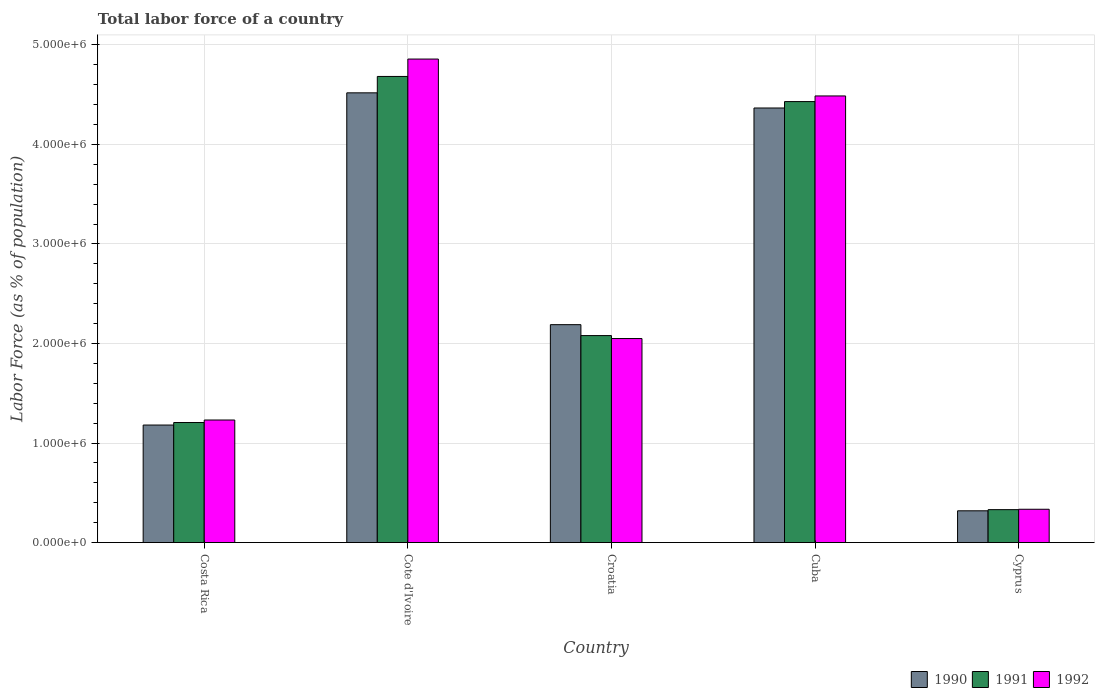How many different coloured bars are there?
Your answer should be compact. 3. Are the number of bars per tick equal to the number of legend labels?
Your answer should be very brief. Yes. Are the number of bars on each tick of the X-axis equal?
Ensure brevity in your answer.  Yes. How many bars are there on the 2nd tick from the left?
Offer a terse response. 3. What is the label of the 3rd group of bars from the left?
Offer a very short reply. Croatia. What is the percentage of labor force in 1992 in Cote d'Ivoire?
Your answer should be compact. 4.86e+06. Across all countries, what is the maximum percentage of labor force in 1991?
Your answer should be very brief. 4.68e+06. Across all countries, what is the minimum percentage of labor force in 1990?
Ensure brevity in your answer.  3.19e+05. In which country was the percentage of labor force in 1991 maximum?
Offer a very short reply. Cote d'Ivoire. In which country was the percentage of labor force in 1991 minimum?
Ensure brevity in your answer.  Cyprus. What is the total percentage of labor force in 1990 in the graph?
Your answer should be very brief. 1.26e+07. What is the difference between the percentage of labor force in 1990 in Cote d'Ivoire and that in Croatia?
Keep it short and to the point. 2.33e+06. What is the difference between the percentage of labor force in 1992 in Cyprus and the percentage of labor force in 1991 in Cote d'Ivoire?
Offer a very short reply. -4.35e+06. What is the average percentage of labor force in 1992 per country?
Your response must be concise. 2.59e+06. What is the difference between the percentage of labor force of/in 1992 and percentage of labor force of/in 1991 in Croatia?
Make the answer very short. -2.97e+04. In how many countries, is the percentage of labor force in 1991 greater than 2200000 %?
Your answer should be compact. 2. What is the ratio of the percentage of labor force in 1990 in Croatia to that in Cyprus?
Give a very brief answer. 6.86. What is the difference between the highest and the second highest percentage of labor force in 1990?
Ensure brevity in your answer.  -2.18e+06. What is the difference between the highest and the lowest percentage of labor force in 1992?
Give a very brief answer. 4.52e+06. In how many countries, is the percentage of labor force in 1990 greater than the average percentage of labor force in 1990 taken over all countries?
Offer a very short reply. 2. What does the 1st bar from the left in Croatia represents?
Offer a very short reply. 1990. How many bars are there?
Offer a terse response. 15. Are all the bars in the graph horizontal?
Your response must be concise. No. How many legend labels are there?
Provide a succinct answer. 3. What is the title of the graph?
Your answer should be compact. Total labor force of a country. What is the label or title of the X-axis?
Provide a short and direct response. Country. What is the label or title of the Y-axis?
Offer a very short reply. Labor Force (as % of population). What is the Labor Force (as % of population) in 1990 in Costa Rica?
Offer a terse response. 1.18e+06. What is the Labor Force (as % of population) of 1991 in Costa Rica?
Offer a terse response. 1.21e+06. What is the Labor Force (as % of population) in 1992 in Costa Rica?
Provide a short and direct response. 1.23e+06. What is the Labor Force (as % of population) in 1990 in Cote d'Ivoire?
Provide a succinct answer. 4.52e+06. What is the Labor Force (as % of population) in 1991 in Cote d'Ivoire?
Provide a succinct answer. 4.68e+06. What is the Labor Force (as % of population) of 1992 in Cote d'Ivoire?
Give a very brief answer. 4.86e+06. What is the Labor Force (as % of population) of 1990 in Croatia?
Make the answer very short. 2.19e+06. What is the Labor Force (as % of population) of 1991 in Croatia?
Your response must be concise. 2.08e+06. What is the Labor Force (as % of population) of 1992 in Croatia?
Provide a short and direct response. 2.05e+06. What is the Labor Force (as % of population) in 1990 in Cuba?
Your answer should be compact. 4.37e+06. What is the Labor Force (as % of population) of 1991 in Cuba?
Your answer should be compact. 4.43e+06. What is the Labor Force (as % of population) of 1992 in Cuba?
Your answer should be very brief. 4.49e+06. What is the Labor Force (as % of population) in 1990 in Cyprus?
Make the answer very short. 3.19e+05. What is the Labor Force (as % of population) of 1991 in Cyprus?
Provide a succinct answer. 3.31e+05. What is the Labor Force (as % of population) of 1992 in Cyprus?
Your response must be concise. 3.35e+05. Across all countries, what is the maximum Labor Force (as % of population) of 1990?
Your answer should be compact. 4.52e+06. Across all countries, what is the maximum Labor Force (as % of population) in 1991?
Provide a succinct answer. 4.68e+06. Across all countries, what is the maximum Labor Force (as % of population) in 1992?
Keep it short and to the point. 4.86e+06. Across all countries, what is the minimum Labor Force (as % of population) of 1990?
Ensure brevity in your answer.  3.19e+05. Across all countries, what is the minimum Labor Force (as % of population) in 1991?
Your answer should be very brief. 3.31e+05. Across all countries, what is the minimum Labor Force (as % of population) in 1992?
Your answer should be very brief. 3.35e+05. What is the total Labor Force (as % of population) of 1990 in the graph?
Your answer should be very brief. 1.26e+07. What is the total Labor Force (as % of population) of 1991 in the graph?
Ensure brevity in your answer.  1.27e+07. What is the total Labor Force (as % of population) in 1992 in the graph?
Your answer should be compact. 1.30e+07. What is the difference between the Labor Force (as % of population) in 1990 in Costa Rica and that in Cote d'Ivoire?
Provide a short and direct response. -3.34e+06. What is the difference between the Labor Force (as % of population) of 1991 in Costa Rica and that in Cote d'Ivoire?
Make the answer very short. -3.48e+06. What is the difference between the Labor Force (as % of population) of 1992 in Costa Rica and that in Cote d'Ivoire?
Ensure brevity in your answer.  -3.63e+06. What is the difference between the Labor Force (as % of population) in 1990 in Costa Rica and that in Croatia?
Your answer should be compact. -1.01e+06. What is the difference between the Labor Force (as % of population) of 1991 in Costa Rica and that in Croatia?
Offer a very short reply. -8.73e+05. What is the difference between the Labor Force (as % of population) of 1992 in Costa Rica and that in Croatia?
Your answer should be compact. -8.19e+05. What is the difference between the Labor Force (as % of population) in 1990 in Costa Rica and that in Cuba?
Keep it short and to the point. -3.19e+06. What is the difference between the Labor Force (as % of population) in 1991 in Costa Rica and that in Cuba?
Ensure brevity in your answer.  -3.22e+06. What is the difference between the Labor Force (as % of population) in 1992 in Costa Rica and that in Cuba?
Make the answer very short. -3.26e+06. What is the difference between the Labor Force (as % of population) of 1990 in Costa Rica and that in Cyprus?
Your response must be concise. 8.62e+05. What is the difference between the Labor Force (as % of population) in 1991 in Costa Rica and that in Cyprus?
Offer a very short reply. 8.75e+05. What is the difference between the Labor Force (as % of population) in 1992 in Costa Rica and that in Cyprus?
Make the answer very short. 8.97e+05. What is the difference between the Labor Force (as % of population) of 1990 in Cote d'Ivoire and that in Croatia?
Your answer should be very brief. 2.33e+06. What is the difference between the Labor Force (as % of population) in 1991 in Cote d'Ivoire and that in Croatia?
Give a very brief answer. 2.60e+06. What is the difference between the Labor Force (as % of population) of 1992 in Cote d'Ivoire and that in Croatia?
Your answer should be compact. 2.81e+06. What is the difference between the Labor Force (as % of population) in 1990 in Cote d'Ivoire and that in Cuba?
Provide a succinct answer. 1.52e+05. What is the difference between the Labor Force (as % of population) of 1991 in Cote d'Ivoire and that in Cuba?
Your answer should be compact. 2.53e+05. What is the difference between the Labor Force (as % of population) of 1992 in Cote d'Ivoire and that in Cuba?
Offer a terse response. 3.71e+05. What is the difference between the Labor Force (as % of population) of 1990 in Cote d'Ivoire and that in Cyprus?
Provide a succinct answer. 4.20e+06. What is the difference between the Labor Force (as % of population) in 1991 in Cote d'Ivoire and that in Cyprus?
Your response must be concise. 4.35e+06. What is the difference between the Labor Force (as % of population) of 1992 in Cote d'Ivoire and that in Cyprus?
Your answer should be compact. 4.52e+06. What is the difference between the Labor Force (as % of population) of 1990 in Croatia and that in Cuba?
Your answer should be very brief. -2.18e+06. What is the difference between the Labor Force (as % of population) of 1991 in Croatia and that in Cuba?
Make the answer very short. -2.35e+06. What is the difference between the Labor Force (as % of population) in 1992 in Croatia and that in Cuba?
Offer a very short reply. -2.44e+06. What is the difference between the Labor Force (as % of population) in 1990 in Croatia and that in Cyprus?
Your response must be concise. 1.87e+06. What is the difference between the Labor Force (as % of population) in 1991 in Croatia and that in Cyprus?
Make the answer very short. 1.75e+06. What is the difference between the Labor Force (as % of population) of 1992 in Croatia and that in Cyprus?
Your response must be concise. 1.72e+06. What is the difference between the Labor Force (as % of population) of 1990 in Cuba and that in Cyprus?
Your response must be concise. 4.05e+06. What is the difference between the Labor Force (as % of population) in 1991 in Cuba and that in Cyprus?
Keep it short and to the point. 4.10e+06. What is the difference between the Labor Force (as % of population) in 1992 in Cuba and that in Cyprus?
Offer a terse response. 4.15e+06. What is the difference between the Labor Force (as % of population) of 1990 in Costa Rica and the Labor Force (as % of population) of 1991 in Cote d'Ivoire?
Your answer should be compact. -3.50e+06. What is the difference between the Labor Force (as % of population) in 1990 in Costa Rica and the Labor Force (as % of population) in 1992 in Cote d'Ivoire?
Offer a terse response. -3.68e+06. What is the difference between the Labor Force (as % of population) of 1991 in Costa Rica and the Labor Force (as % of population) of 1992 in Cote d'Ivoire?
Your answer should be very brief. -3.65e+06. What is the difference between the Labor Force (as % of population) in 1990 in Costa Rica and the Labor Force (as % of population) in 1991 in Croatia?
Your response must be concise. -8.99e+05. What is the difference between the Labor Force (as % of population) of 1990 in Costa Rica and the Labor Force (as % of population) of 1992 in Croatia?
Give a very brief answer. -8.69e+05. What is the difference between the Labor Force (as % of population) of 1991 in Costa Rica and the Labor Force (as % of population) of 1992 in Croatia?
Provide a short and direct response. -8.44e+05. What is the difference between the Labor Force (as % of population) in 1990 in Costa Rica and the Labor Force (as % of population) in 1991 in Cuba?
Your answer should be compact. -3.25e+06. What is the difference between the Labor Force (as % of population) of 1990 in Costa Rica and the Labor Force (as % of population) of 1992 in Cuba?
Provide a succinct answer. -3.31e+06. What is the difference between the Labor Force (as % of population) in 1991 in Costa Rica and the Labor Force (as % of population) in 1992 in Cuba?
Keep it short and to the point. -3.28e+06. What is the difference between the Labor Force (as % of population) of 1990 in Costa Rica and the Labor Force (as % of population) of 1991 in Cyprus?
Your answer should be compact. 8.50e+05. What is the difference between the Labor Force (as % of population) in 1990 in Costa Rica and the Labor Force (as % of population) in 1992 in Cyprus?
Offer a terse response. 8.46e+05. What is the difference between the Labor Force (as % of population) in 1991 in Costa Rica and the Labor Force (as % of population) in 1992 in Cyprus?
Offer a terse response. 8.71e+05. What is the difference between the Labor Force (as % of population) of 1990 in Cote d'Ivoire and the Labor Force (as % of population) of 1991 in Croatia?
Ensure brevity in your answer.  2.44e+06. What is the difference between the Labor Force (as % of population) of 1990 in Cote d'Ivoire and the Labor Force (as % of population) of 1992 in Croatia?
Offer a very short reply. 2.47e+06. What is the difference between the Labor Force (as % of population) in 1991 in Cote d'Ivoire and the Labor Force (as % of population) in 1992 in Croatia?
Ensure brevity in your answer.  2.63e+06. What is the difference between the Labor Force (as % of population) in 1990 in Cote d'Ivoire and the Labor Force (as % of population) in 1991 in Cuba?
Offer a very short reply. 8.79e+04. What is the difference between the Labor Force (as % of population) in 1990 in Cote d'Ivoire and the Labor Force (as % of population) in 1992 in Cuba?
Provide a short and direct response. 3.12e+04. What is the difference between the Labor Force (as % of population) of 1991 in Cote d'Ivoire and the Labor Force (as % of population) of 1992 in Cuba?
Your answer should be very brief. 1.96e+05. What is the difference between the Labor Force (as % of population) of 1990 in Cote d'Ivoire and the Labor Force (as % of population) of 1991 in Cyprus?
Provide a succinct answer. 4.19e+06. What is the difference between the Labor Force (as % of population) of 1990 in Cote d'Ivoire and the Labor Force (as % of population) of 1992 in Cyprus?
Give a very brief answer. 4.18e+06. What is the difference between the Labor Force (as % of population) in 1991 in Cote d'Ivoire and the Labor Force (as % of population) in 1992 in Cyprus?
Keep it short and to the point. 4.35e+06. What is the difference between the Labor Force (as % of population) of 1990 in Croatia and the Labor Force (as % of population) of 1991 in Cuba?
Make the answer very short. -2.24e+06. What is the difference between the Labor Force (as % of population) in 1990 in Croatia and the Labor Force (as % of population) in 1992 in Cuba?
Make the answer very short. -2.30e+06. What is the difference between the Labor Force (as % of population) of 1991 in Croatia and the Labor Force (as % of population) of 1992 in Cuba?
Make the answer very short. -2.41e+06. What is the difference between the Labor Force (as % of population) in 1990 in Croatia and the Labor Force (as % of population) in 1991 in Cyprus?
Your response must be concise. 1.86e+06. What is the difference between the Labor Force (as % of population) in 1990 in Croatia and the Labor Force (as % of population) in 1992 in Cyprus?
Offer a very short reply. 1.85e+06. What is the difference between the Labor Force (as % of population) of 1991 in Croatia and the Labor Force (as % of population) of 1992 in Cyprus?
Give a very brief answer. 1.74e+06. What is the difference between the Labor Force (as % of population) in 1990 in Cuba and the Labor Force (as % of population) in 1991 in Cyprus?
Your answer should be very brief. 4.04e+06. What is the difference between the Labor Force (as % of population) in 1990 in Cuba and the Labor Force (as % of population) in 1992 in Cyprus?
Your answer should be compact. 4.03e+06. What is the difference between the Labor Force (as % of population) of 1991 in Cuba and the Labor Force (as % of population) of 1992 in Cyprus?
Keep it short and to the point. 4.10e+06. What is the average Labor Force (as % of population) in 1990 per country?
Your answer should be very brief. 2.51e+06. What is the average Labor Force (as % of population) of 1991 per country?
Keep it short and to the point. 2.55e+06. What is the average Labor Force (as % of population) of 1992 per country?
Offer a terse response. 2.59e+06. What is the difference between the Labor Force (as % of population) of 1990 and Labor Force (as % of population) of 1991 in Costa Rica?
Keep it short and to the point. -2.54e+04. What is the difference between the Labor Force (as % of population) of 1990 and Labor Force (as % of population) of 1992 in Costa Rica?
Offer a terse response. -5.05e+04. What is the difference between the Labor Force (as % of population) in 1991 and Labor Force (as % of population) in 1992 in Costa Rica?
Offer a very short reply. -2.52e+04. What is the difference between the Labor Force (as % of population) of 1990 and Labor Force (as % of population) of 1991 in Cote d'Ivoire?
Your answer should be very brief. -1.65e+05. What is the difference between the Labor Force (as % of population) in 1990 and Labor Force (as % of population) in 1992 in Cote d'Ivoire?
Your response must be concise. -3.39e+05. What is the difference between the Labor Force (as % of population) in 1991 and Labor Force (as % of population) in 1992 in Cote d'Ivoire?
Make the answer very short. -1.75e+05. What is the difference between the Labor Force (as % of population) in 1990 and Labor Force (as % of population) in 1991 in Croatia?
Make the answer very short. 1.10e+05. What is the difference between the Labor Force (as % of population) of 1990 and Labor Force (as % of population) of 1992 in Croatia?
Provide a short and direct response. 1.39e+05. What is the difference between the Labor Force (as % of population) in 1991 and Labor Force (as % of population) in 1992 in Croatia?
Your response must be concise. 2.97e+04. What is the difference between the Labor Force (as % of population) of 1990 and Labor Force (as % of population) of 1991 in Cuba?
Your answer should be very brief. -6.43e+04. What is the difference between the Labor Force (as % of population) in 1990 and Labor Force (as % of population) in 1992 in Cuba?
Your answer should be compact. -1.21e+05. What is the difference between the Labor Force (as % of population) in 1991 and Labor Force (as % of population) in 1992 in Cuba?
Make the answer very short. -5.67e+04. What is the difference between the Labor Force (as % of population) in 1990 and Labor Force (as % of population) in 1991 in Cyprus?
Your answer should be very brief. -1.16e+04. What is the difference between the Labor Force (as % of population) in 1990 and Labor Force (as % of population) in 1992 in Cyprus?
Give a very brief answer. -1.55e+04. What is the difference between the Labor Force (as % of population) of 1991 and Labor Force (as % of population) of 1992 in Cyprus?
Offer a very short reply. -3948. What is the ratio of the Labor Force (as % of population) of 1990 in Costa Rica to that in Cote d'Ivoire?
Offer a terse response. 0.26. What is the ratio of the Labor Force (as % of population) in 1991 in Costa Rica to that in Cote d'Ivoire?
Give a very brief answer. 0.26. What is the ratio of the Labor Force (as % of population) in 1992 in Costa Rica to that in Cote d'Ivoire?
Your answer should be compact. 0.25. What is the ratio of the Labor Force (as % of population) in 1990 in Costa Rica to that in Croatia?
Provide a short and direct response. 0.54. What is the ratio of the Labor Force (as % of population) in 1991 in Costa Rica to that in Croatia?
Provide a short and direct response. 0.58. What is the ratio of the Labor Force (as % of population) of 1992 in Costa Rica to that in Croatia?
Give a very brief answer. 0.6. What is the ratio of the Labor Force (as % of population) in 1990 in Costa Rica to that in Cuba?
Your answer should be very brief. 0.27. What is the ratio of the Labor Force (as % of population) in 1991 in Costa Rica to that in Cuba?
Your answer should be compact. 0.27. What is the ratio of the Labor Force (as % of population) in 1992 in Costa Rica to that in Cuba?
Offer a very short reply. 0.27. What is the ratio of the Labor Force (as % of population) in 1990 in Costa Rica to that in Cyprus?
Keep it short and to the point. 3.7. What is the ratio of the Labor Force (as % of population) in 1991 in Costa Rica to that in Cyprus?
Provide a succinct answer. 3.65. What is the ratio of the Labor Force (as % of population) of 1992 in Costa Rica to that in Cyprus?
Offer a very short reply. 3.68. What is the ratio of the Labor Force (as % of population) in 1990 in Cote d'Ivoire to that in Croatia?
Your answer should be very brief. 2.06. What is the ratio of the Labor Force (as % of population) of 1991 in Cote d'Ivoire to that in Croatia?
Keep it short and to the point. 2.25. What is the ratio of the Labor Force (as % of population) of 1992 in Cote d'Ivoire to that in Croatia?
Ensure brevity in your answer.  2.37. What is the ratio of the Labor Force (as % of population) in 1990 in Cote d'Ivoire to that in Cuba?
Your answer should be very brief. 1.03. What is the ratio of the Labor Force (as % of population) in 1991 in Cote d'Ivoire to that in Cuba?
Keep it short and to the point. 1.06. What is the ratio of the Labor Force (as % of population) of 1992 in Cote d'Ivoire to that in Cuba?
Give a very brief answer. 1.08. What is the ratio of the Labor Force (as % of population) of 1990 in Cote d'Ivoire to that in Cyprus?
Your response must be concise. 14.15. What is the ratio of the Labor Force (as % of population) of 1991 in Cote d'Ivoire to that in Cyprus?
Give a very brief answer. 14.15. What is the ratio of the Labor Force (as % of population) of 1992 in Cote d'Ivoire to that in Cyprus?
Give a very brief answer. 14.51. What is the ratio of the Labor Force (as % of population) of 1990 in Croatia to that in Cuba?
Your response must be concise. 0.5. What is the ratio of the Labor Force (as % of population) of 1991 in Croatia to that in Cuba?
Your response must be concise. 0.47. What is the ratio of the Labor Force (as % of population) in 1992 in Croatia to that in Cuba?
Your answer should be very brief. 0.46. What is the ratio of the Labor Force (as % of population) in 1990 in Croatia to that in Cyprus?
Give a very brief answer. 6.86. What is the ratio of the Labor Force (as % of population) in 1991 in Croatia to that in Cyprus?
Your answer should be very brief. 6.29. What is the ratio of the Labor Force (as % of population) in 1992 in Croatia to that in Cyprus?
Ensure brevity in your answer.  6.12. What is the ratio of the Labor Force (as % of population) of 1990 in Cuba to that in Cyprus?
Offer a very short reply. 13.67. What is the ratio of the Labor Force (as % of population) of 1991 in Cuba to that in Cyprus?
Your answer should be very brief. 13.39. What is the ratio of the Labor Force (as % of population) of 1992 in Cuba to that in Cyprus?
Make the answer very short. 13.4. What is the difference between the highest and the second highest Labor Force (as % of population) of 1990?
Ensure brevity in your answer.  1.52e+05. What is the difference between the highest and the second highest Labor Force (as % of population) of 1991?
Keep it short and to the point. 2.53e+05. What is the difference between the highest and the second highest Labor Force (as % of population) in 1992?
Ensure brevity in your answer.  3.71e+05. What is the difference between the highest and the lowest Labor Force (as % of population) of 1990?
Keep it short and to the point. 4.20e+06. What is the difference between the highest and the lowest Labor Force (as % of population) of 1991?
Ensure brevity in your answer.  4.35e+06. What is the difference between the highest and the lowest Labor Force (as % of population) of 1992?
Your answer should be compact. 4.52e+06. 